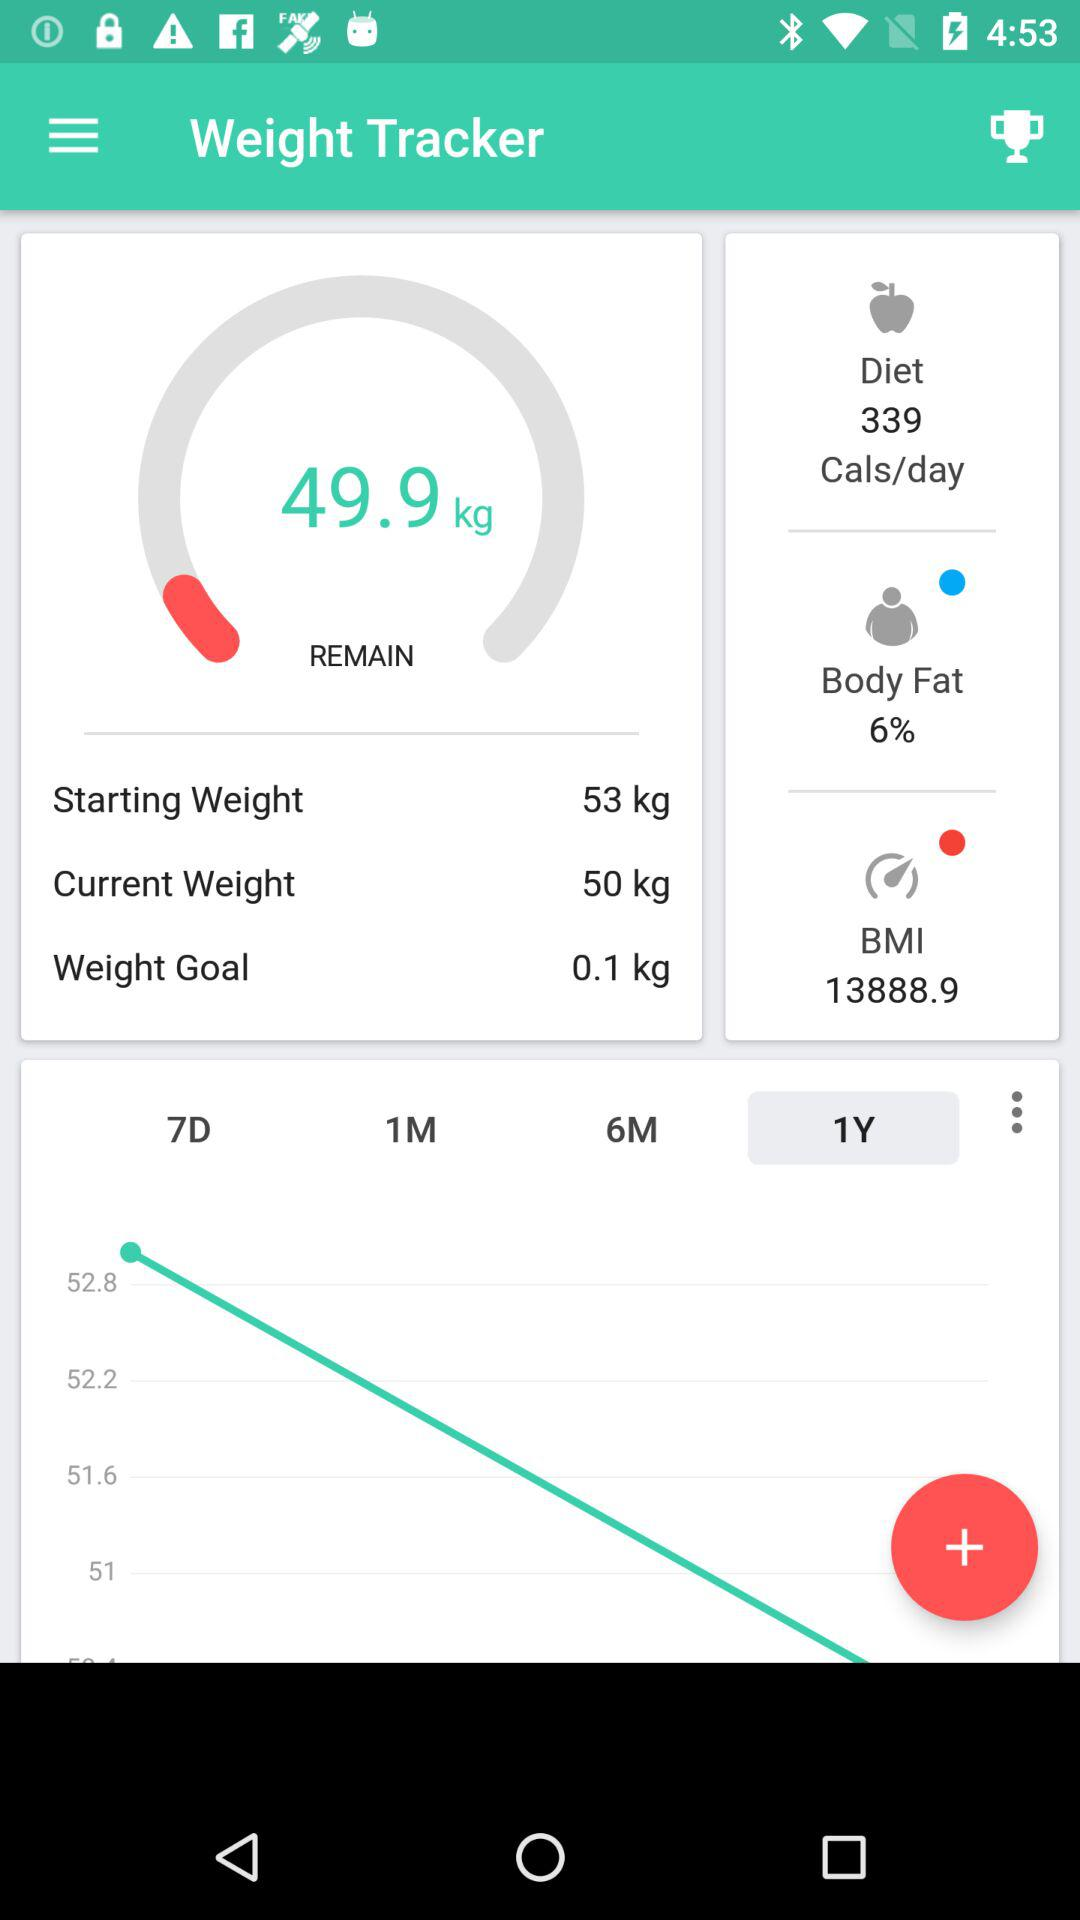How much body fat percentage has been lost since starting the weight tracker?
When the provided information is insufficient, respond with <no answer>. <no answer> 